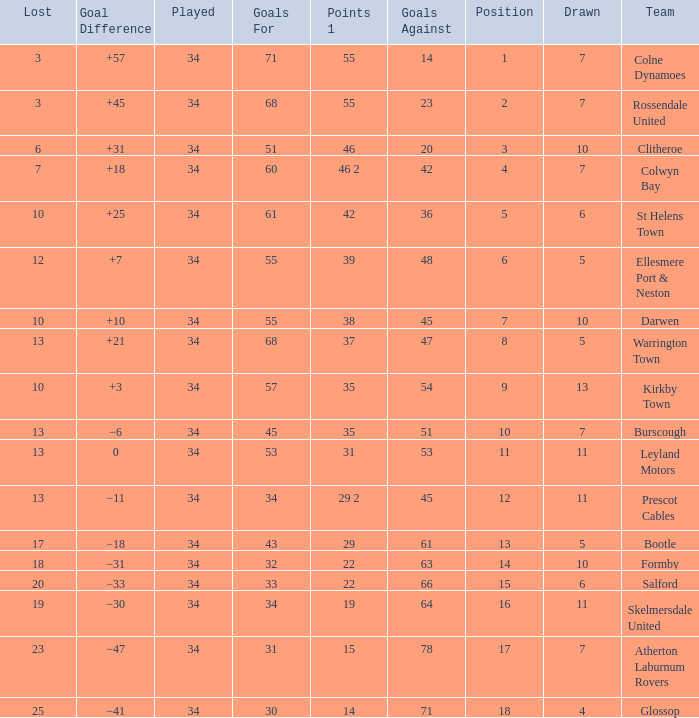How many Drawn have a Lost smaller than 25, and a Goal Difference of +7, and a Played larger than 34? 0.0. 